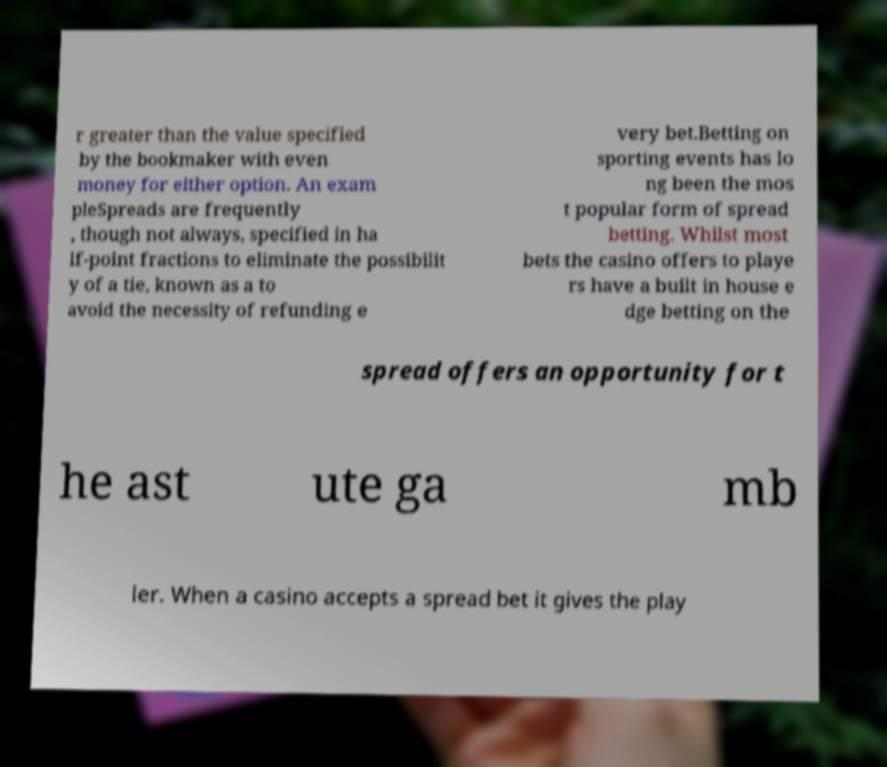Can you read and provide the text displayed in the image?This photo seems to have some interesting text. Can you extract and type it out for me? r greater than the value specified by the bookmaker with even money for either option. An exam pleSpreads are frequently , though not always, specified in ha lf-point fractions to eliminate the possibilit y of a tie, known as a to avoid the necessity of refunding e very bet.Betting on sporting events has lo ng been the mos t popular form of spread betting. Whilst most bets the casino offers to playe rs have a built in house e dge betting on the spread offers an opportunity for t he ast ute ga mb ler. When a casino accepts a spread bet it gives the play 